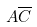Convert formula to latex. <formula><loc_0><loc_0><loc_500><loc_500>A \overline { C }</formula> 